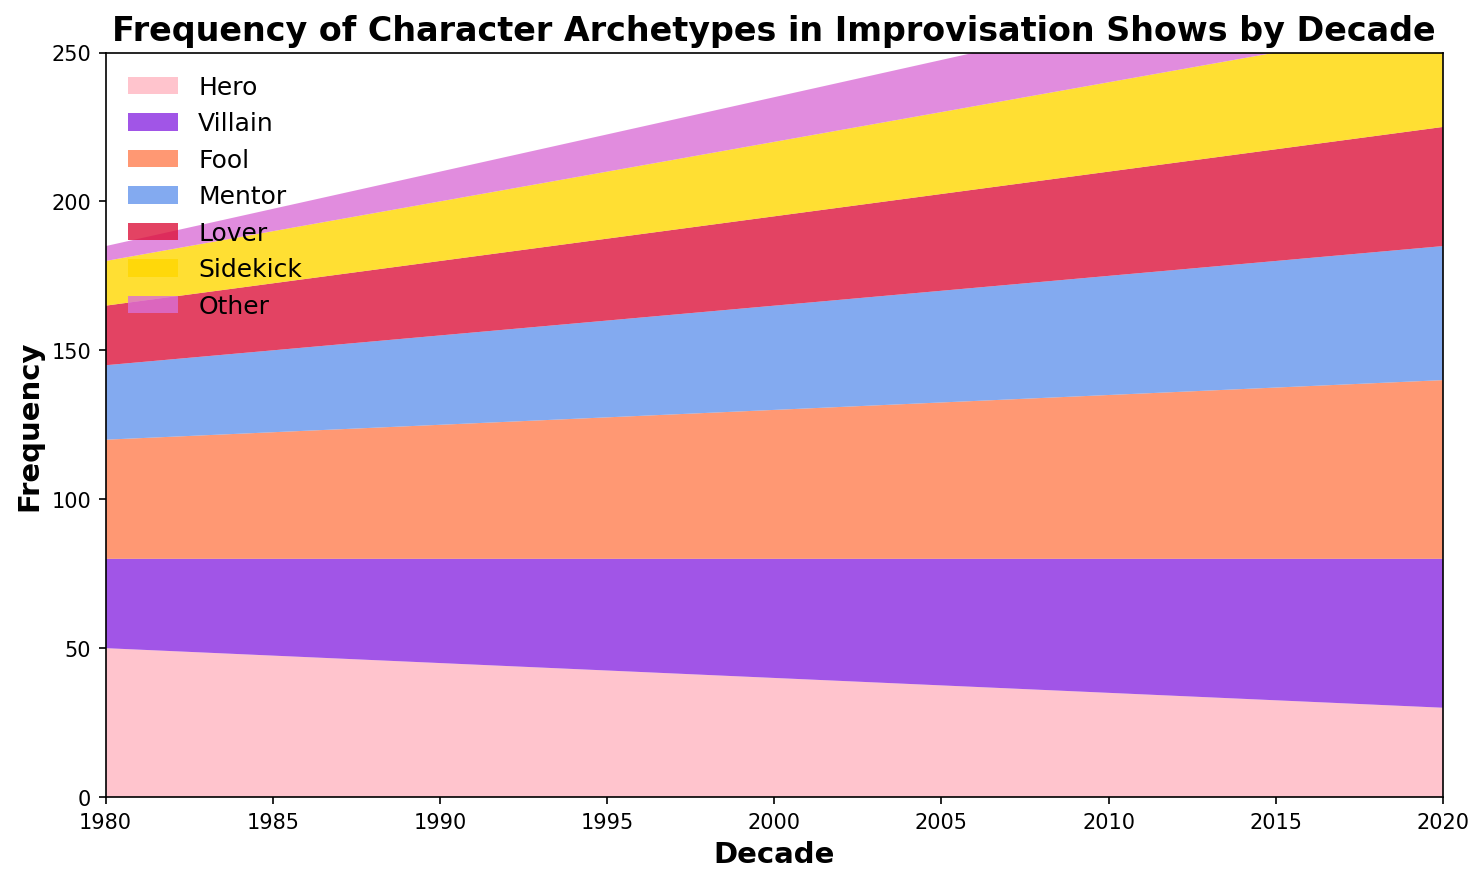Which character archetype showed the largest increase in frequency from the 1980s to the 2020s? To determine which archetype showed the largest increase, we need to calculate the difference in frequency for each archetype between the 1980s and 2020s. Hero: 30-50 = -20, Villain: 50-30 = 20, Fool: 60-40 = 20, Mentor: 45-25 = 20, Lover: 40-20 = 20, Sidekick: 35-15 = 20, Other: 25-5 = 20. All archetypes except Hero increased by 20.
Answer: Villain, Fool, Mentor, Lover, Sidekick, Other Which decade had the highest frequency of the 'Fool' archetype? To find the decade with the highest frequency of the 'Fool' archetype, we compare the 'Fool' values across all decades. 1980: 40, 1990: 45, 2000: 50, 2010: 55, 2020: 60. The 2020s had the highest frequency with 60.
Answer: 2020 Which two archetypes had the closest frequencies in the 1990s? We compare the frequencies of each archetype in the 1990s. Hero: 45, Villain: 35, Fool: 45, Mentor: 30, Lover: 25, Sidekick: 20, Other: 10. 'Hero' and 'Fool' both had the same frequency of 45.
Answer: Hero and Fool What is the average frequency of the 'Mentor' archetype across all decades? Sum the frequencies of 'Mentor' across all decades and divide by the number of decades: (25 + 30 + 35 + 40 + 45) / 5 = 35.
Answer: 35 In which decade did the 'Hero' archetype have the steepest decline in frequency? To determine the steepest decline, compare the frequency of 'Hero' between consecutive decades: 1980-1990: 50-45=-5, 1990-2000: 45-40=-5, 2000-2010: 40-35=-5, 2010-2020: 35-30=-5. The decline was consistent with -5 per decade. Therefore, there is no single decade with a steeper decline.
Answer: All decades (consistent decline) What was the combined frequency of 'Lover' and 'Sidekick' in the 2010s? Add the frequencies of 'Lover' and 'Sidekick' in the 2010s: 35 + 30 = 65.
Answer: 65 Which archetype has consistently increased in frequency every decade? By examining the frequency trends for each archetype: Hero decreased, Villain increased, Fool increased, Mentor increased, Lover increased, Sidekick increased, Other increased. All archetypes except Hero increased consistently.
Answer: Villain, Fool, Mentor, Lover, Sidekick, Other Between which two consecutive decades did the 'Villain' archetype see the greatest increase in frequency? Calculate the increase between consecutive decades: 1980-1990: 5, 1990-2000: 5, 2000-2010: 5, 2010-2020: 5. All increases are equal to 5, so there is no greatest increase, just equal increases.
Answer: All consecutive decades (consistent increase) Compare the frequency of 'Other' in the 1980s to its frequency in the 2020s. Which decade had the highest frequency? Compare the frequencies: 1980: 5, 2020: 25. The 2020s have the higher frequency.
Answer: 2020 